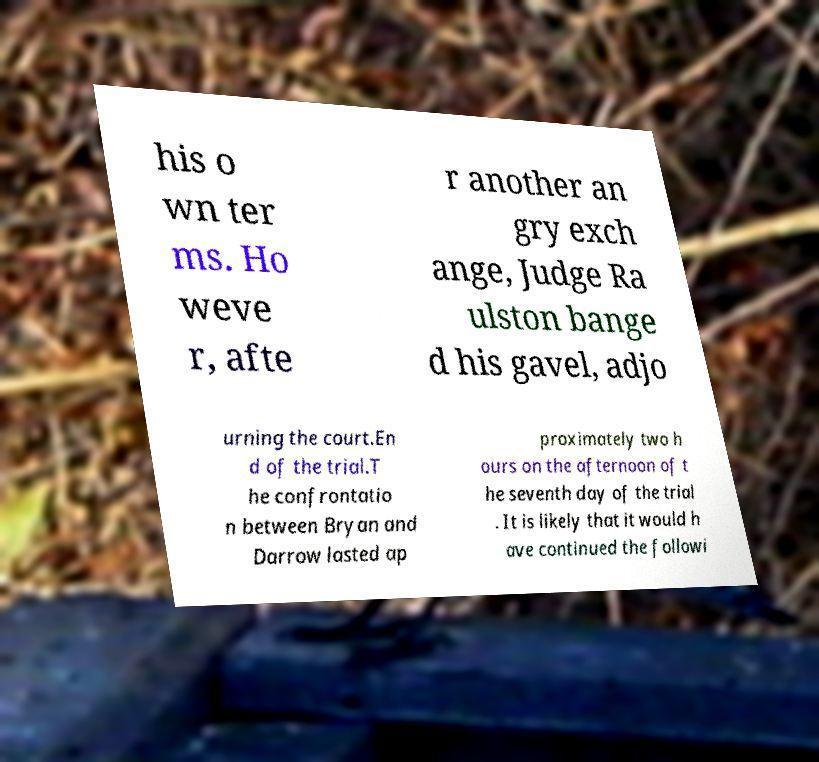Can you accurately transcribe the text from the provided image for me? his o wn ter ms. Ho weve r, afte r another an gry exch ange, Judge Ra ulston bange d his gavel, adjo urning the court.En d of the trial.T he confrontatio n between Bryan and Darrow lasted ap proximately two h ours on the afternoon of t he seventh day of the trial . It is likely that it would h ave continued the followi 